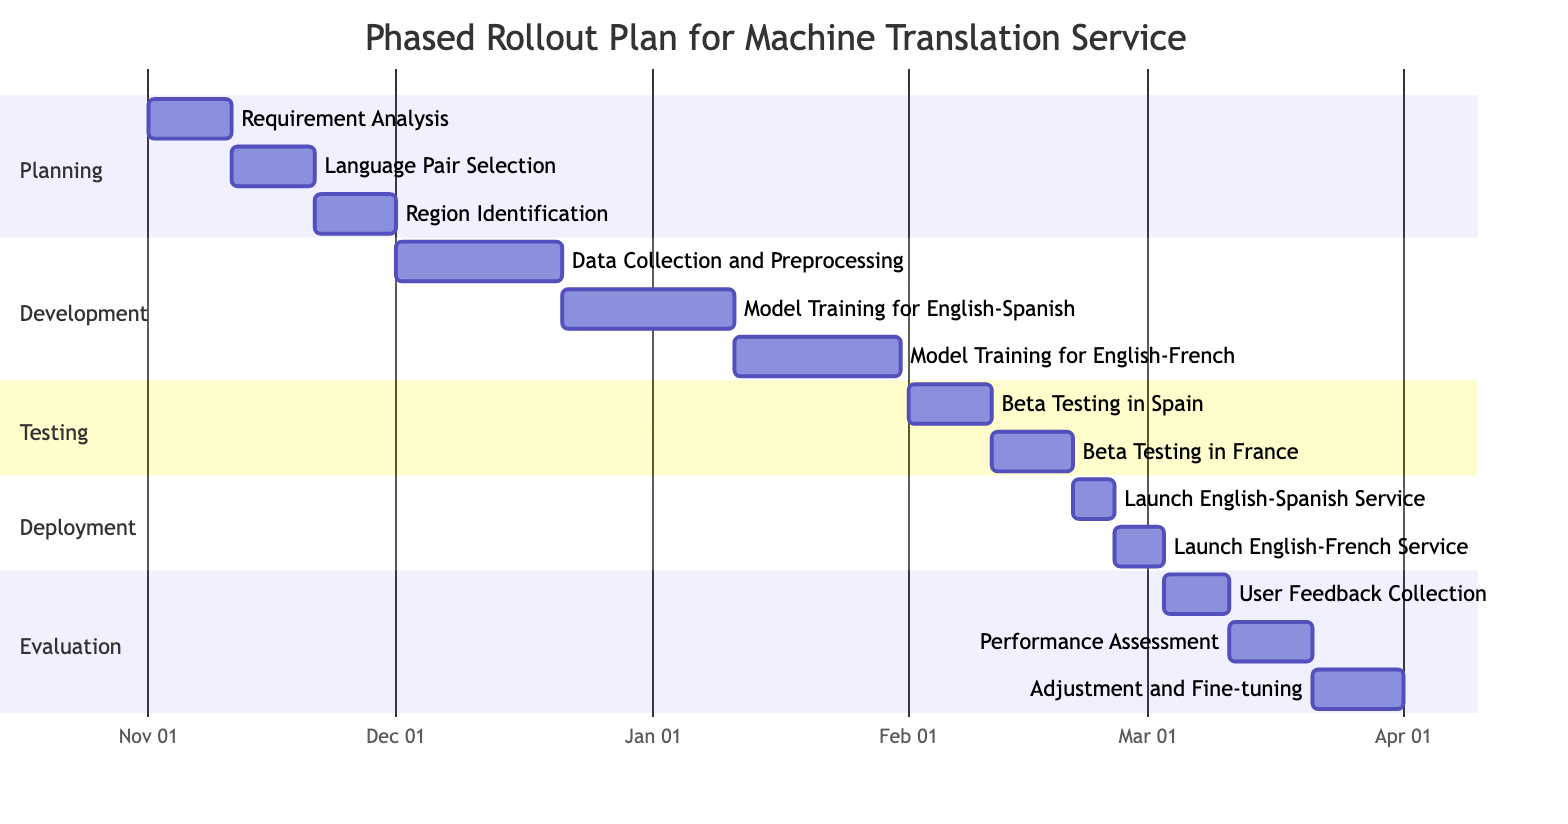What is the duration of the "Model Training for English-Spanish" task? The task starts on December 21, 2023, and ends on January 10, 2024. To calculate the duration, we note that January 10 is 21 days after December 21, so the duration is 21 days.
Answer: 21 days How many tasks are in the "Evaluation" phase? The "Evaluation" phase contains three tasks: "User Feedback Collection," "Performance Assessment," and "Adjustment and Fine-tuning." Counting these tasks gives a total of three.
Answer: 3 Which task follows "Language Pair Selection"? The "Language Pair Selection" task ends on November 20, 2023. The next task, "Region Identification," starts on November 21, 2023. Thus, "Region Identification" follows "Language Pair Selection."
Answer: Region Identification What is the start date of the "Beta Testing in France" task? The task "Beta Testing in France" starts on February 11, 2024. This can be directly determined from the Gantt Chart where the task is listed.
Answer: February 11, 2024 Which two tasks have overlapping timelines? "Model Training for English-French" starts on January 11, 2024, and ends on January 30, 2024, while "Beta Testing in Spain" starts on February 1, 2024. These two tasks do not overlap. However, "Data Collection and Preprocessing" runs from December 1 to December 20, 2023, and "Model Training for English-Spanish" continues from December 21 to January 10, 2024. These two tasks overlap since the former ends right before the latter starts.
Answer: Data Collection and Preprocessing, Model Training for English-Spanish What is the last task in the "Deployment" phase? The last task in the "Deployment" phase is "Launch English-French Service," which starts on February 26, 2024, and ends on March 2, 2024. This can be observed as the last entry under the "Deployment" section of the Gantt Chart.
Answer: Launch English-French Service 